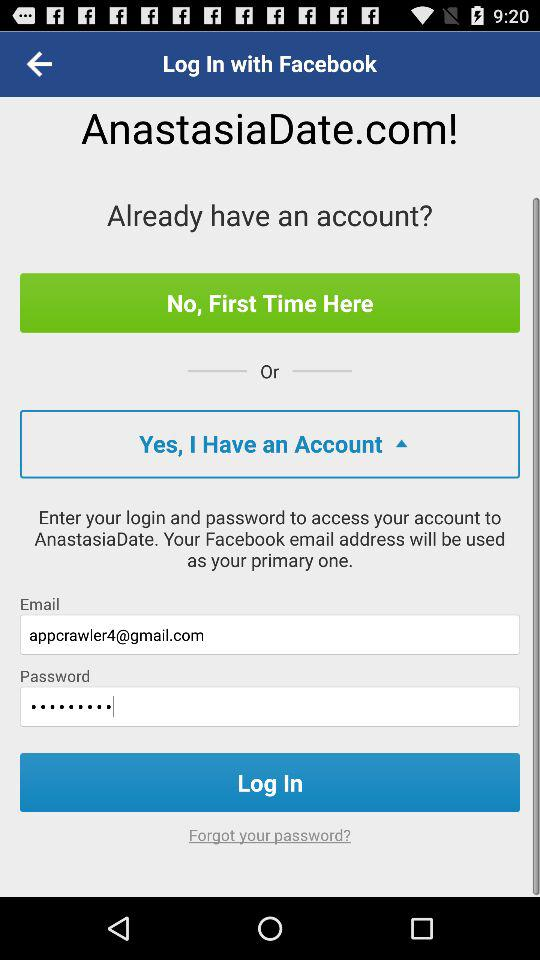What is the email address? The email address is appcrawler4@gmail.com. 